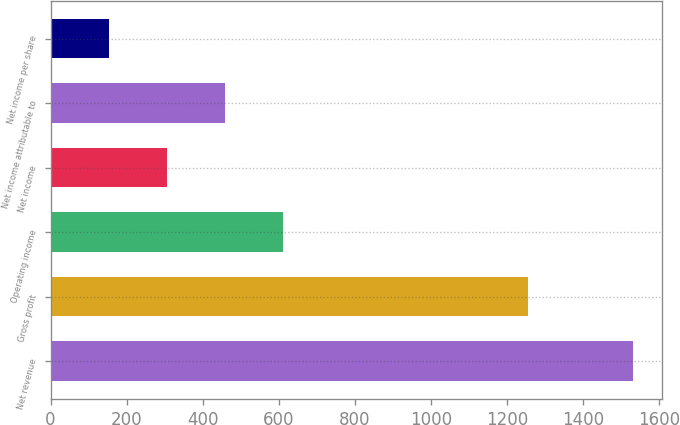Convert chart to OTSL. <chart><loc_0><loc_0><loc_500><loc_500><bar_chart><fcel>Net revenue<fcel>Gross profit<fcel>Operating income<fcel>Net income<fcel>Net income attributable to<fcel>Net income per share<nl><fcel>1531<fcel>1255<fcel>612.55<fcel>306.39<fcel>459.47<fcel>153.31<nl></chart> 